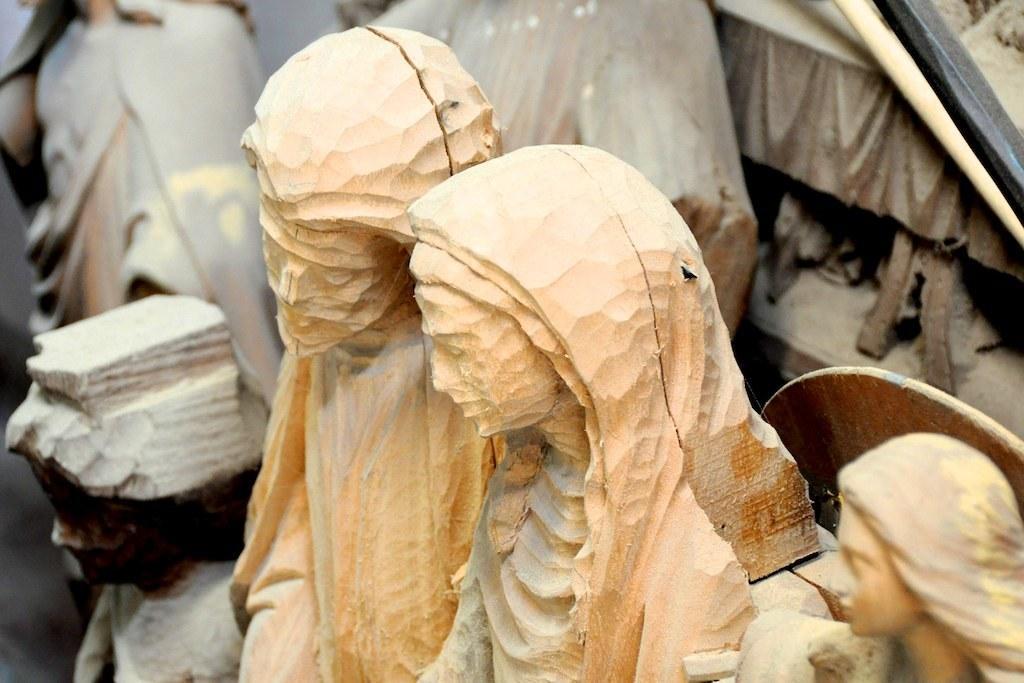How would you summarize this image in a sentence or two? In this image we can see statues. We can see wood and metal rod in the right top of the image. 